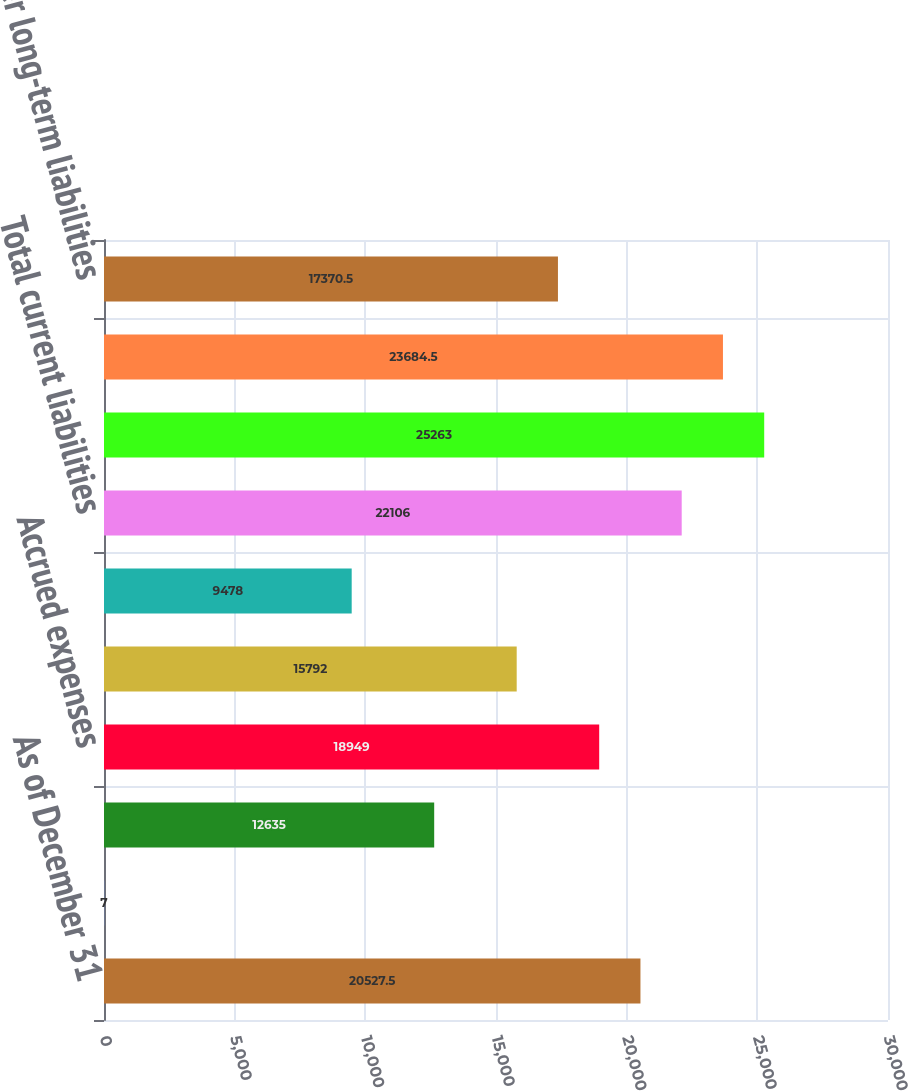Convert chart to OTSL. <chart><loc_0><loc_0><loc_500><loc_500><bar_chart><fcel>As of December 31<fcel>Current debt obligations<fcel>Accounts payable<fcel>Accrued expenses<fcel>Income taxes payable<fcel>Other current liabilities<fcel>Total current liabilities<fcel>Long-term debt<fcel>Deferred income taxes<fcel>Other long-term liabilities<nl><fcel>20527.5<fcel>7<fcel>12635<fcel>18949<fcel>15792<fcel>9478<fcel>22106<fcel>25263<fcel>23684.5<fcel>17370.5<nl></chart> 